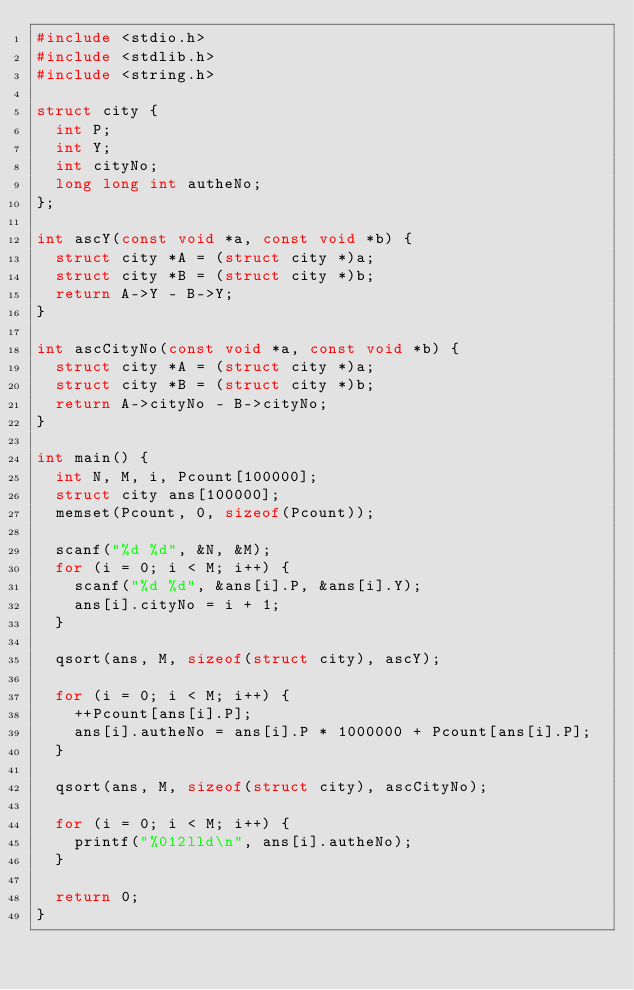Convert code to text. <code><loc_0><loc_0><loc_500><loc_500><_C_>#include <stdio.h>
#include <stdlib.h>
#include <string.h>

struct city {
	int P;
	int Y;
	int cityNo;
	long long int autheNo;
};

int ascY(const void *a, const void *b) {
	struct city *A = (struct city *)a;
	struct city *B = (struct city *)b;
	return A->Y - B->Y;
}

int ascCityNo(const void *a, const void *b) {
	struct city *A = (struct city *)a;
	struct city *B = (struct city *)b;
	return A->cityNo - B->cityNo;
}

int main() {
	int N, M, i, Pcount[100000];
	struct city ans[100000];
	memset(Pcount, 0, sizeof(Pcount));

	scanf("%d %d", &N, &M);
	for (i = 0; i < M; i++) {
		scanf("%d %d", &ans[i].P, &ans[i].Y);
		ans[i].cityNo = i + 1;
	}

	qsort(ans, M, sizeof(struct city), ascY);

	for (i = 0; i < M; i++) {
		++Pcount[ans[i].P];
		ans[i].autheNo = ans[i].P * 1000000 + Pcount[ans[i].P];
	}

	qsort(ans, M, sizeof(struct city), ascCityNo);

	for (i = 0; i < M; i++) {
		printf("%012lld\n", ans[i].autheNo);
	}

	return 0;
}</code> 